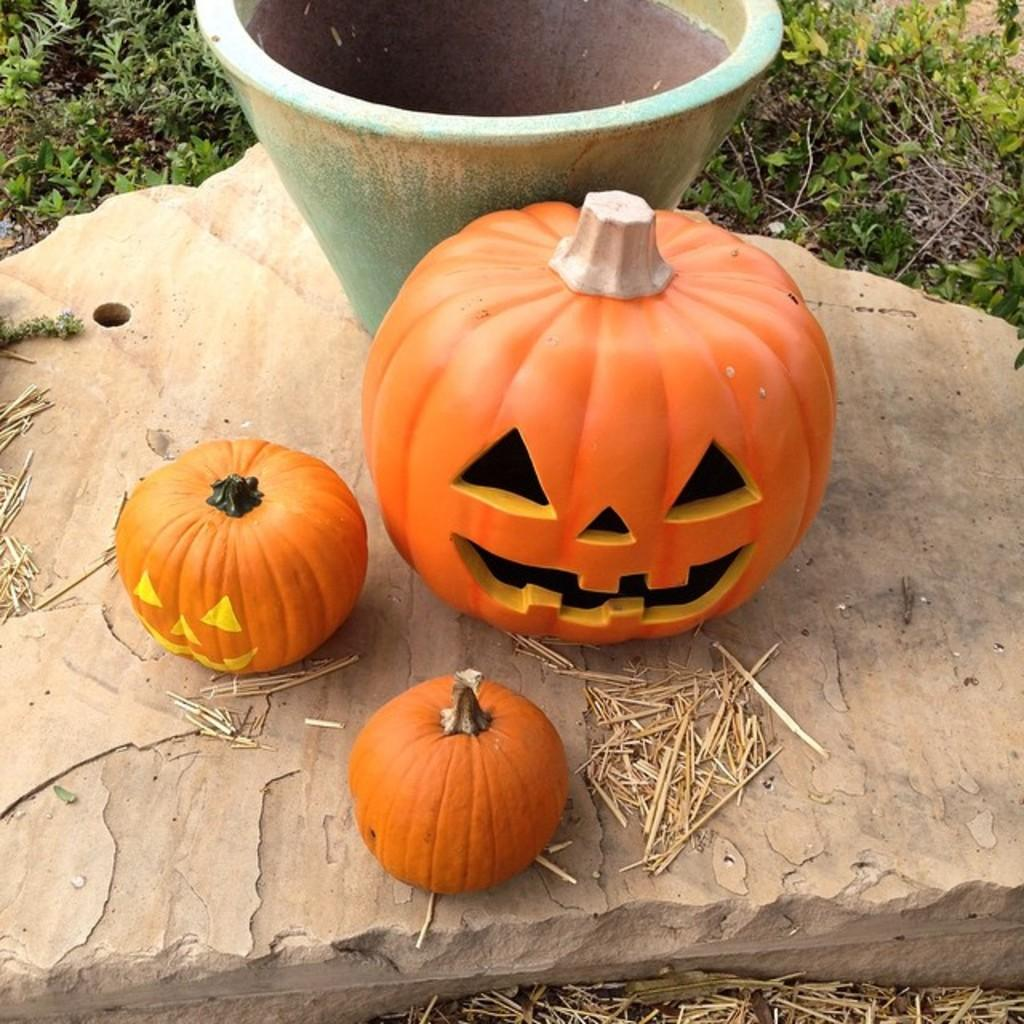How many pumpkins are present in the image? There are three pumpkins in the image. What else is present in the image besides the pumpkins? There is a plant pot in the image. Where are the pumpkins and plant pot located? They are kept on a rock in the image. Are there any other plants visible in the image? Yes, there are small plants visible in the image. What type of fan is visible in the image? There is no fan present in the image. 